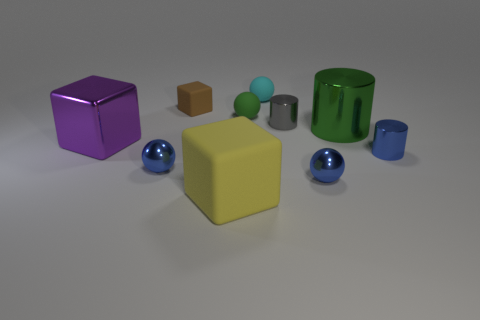Subtract all gray blocks. How many blue balls are left? 2 Subtract all rubber blocks. How many blocks are left? 1 Subtract 1 blocks. How many blocks are left? 2 Subtract all brown spheres. Subtract all red cylinders. How many spheres are left? 4 Subtract all cubes. How many objects are left? 7 Add 8 tiny matte spheres. How many tiny matte spheres are left? 10 Add 5 large purple things. How many large purple things exist? 6 Subtract 1 green cylinders. How many objects are left? 9 Subtract all tiny brown cubes. Subtract all cyan matte objects. How many objects are left? 8 